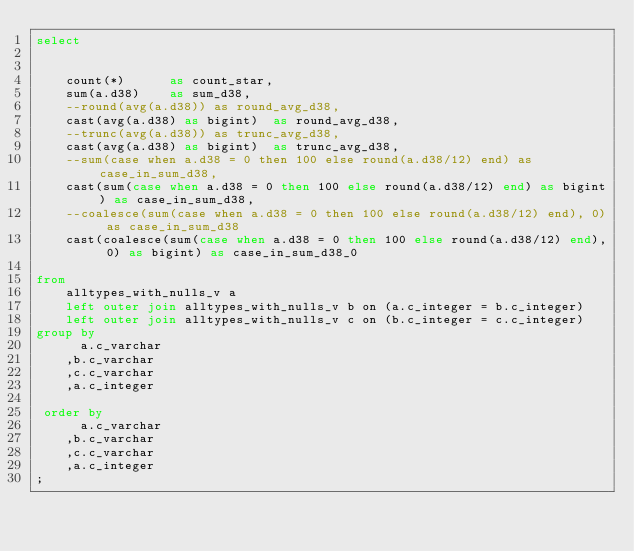<code> <loc_0><loc_0><loc_500><loc_500><_SQL_>select

				
		count(*)			as count_star,
 		sum(a.d38)		as sum_d38,
 		--round(avg(a.d38))	as round_avg_d38,
 		cast(avg(a.d38) as bigint)	as round_avg_d38,
 		--trunc(avg(a.d38))	as trunc_avg_d38,
 		cast(avg(a.d38) as bigint)	as trunc_avg_d38,
 		--sum(case when a.d38 = 0 then 100 else round(a.d38/12) end) as case_in_sum_d38,
 		cast(sum(case when a.d38 = 0 then 100 else round(a.d38/12) end) as bigint) as case_in_sum_d38,
 		--coalesce(sum(case when a.d38 = 0 then 100 else round(a.d38/12) end), 0) as case_in_sum_d38
 		cast(coalesce(sum(case when a.d38 = 0 then 100 else round(a.d38/12) end), 0) as bigint) as case_in_sum_d38_0
 
from
 		alltypes_with_nulls_v a
		left outer join alltypes_with_nulls_v b on (a.c_integer = b.c_integer)
		left outer join alltypes_with_nulls_v c on (b.c_integer = c.c_integer)
group by
  		a.c_varchar
 		,b.c_varchar
 		,c.c_varchar
 		,a.c_integer

 order by
  		a.c_varchar
 		,b.c_varchar
 		,c.c_varchar
 		,a.c_integer
;
</code> 